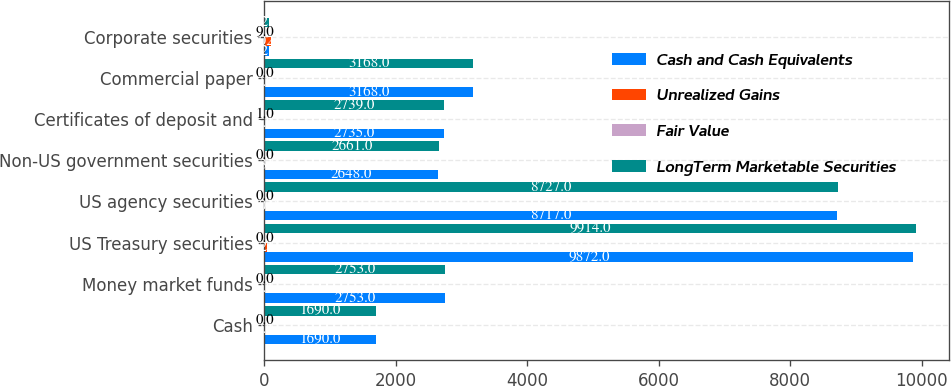<chart> <loc_0><loc_0><loc_500><loc_500><stacked_bar_chart><ecel><fcel>Cash<fcel>Money market funds<fcel>US Treasury securities<fcel>US agency securities<fcel>Non-US government securities<fcel>Certificates of deposit and<fcel>Commercial paper<fcel>Corporate securities<nl><fcel>Cash and Cash Equivalents<fcel>1690<fcel>2753<fcel>9872<fcel>8717<fcel>2648<fcel>2735<fcel>3168<fcel>72<nl><fcel>Unrealized Gains<fcel>0<fcel>0<fcel>42<fcel>10<fcel>13<fcel>5<fcel>0<fcel>102<nl><fcel>Fair Value<fcel>0<fcel>0<fcel>0<fcel>0<fcel>0<fcel>1<fcel>0<fcel>9<nl><fcel>LongTerm Marketable Securities<fcel>1690<fcel>2753<fcel>9914<fcel>8727<fcel>2661<fcel>2739<fcel>3168<fcel>72<nl></chart> 